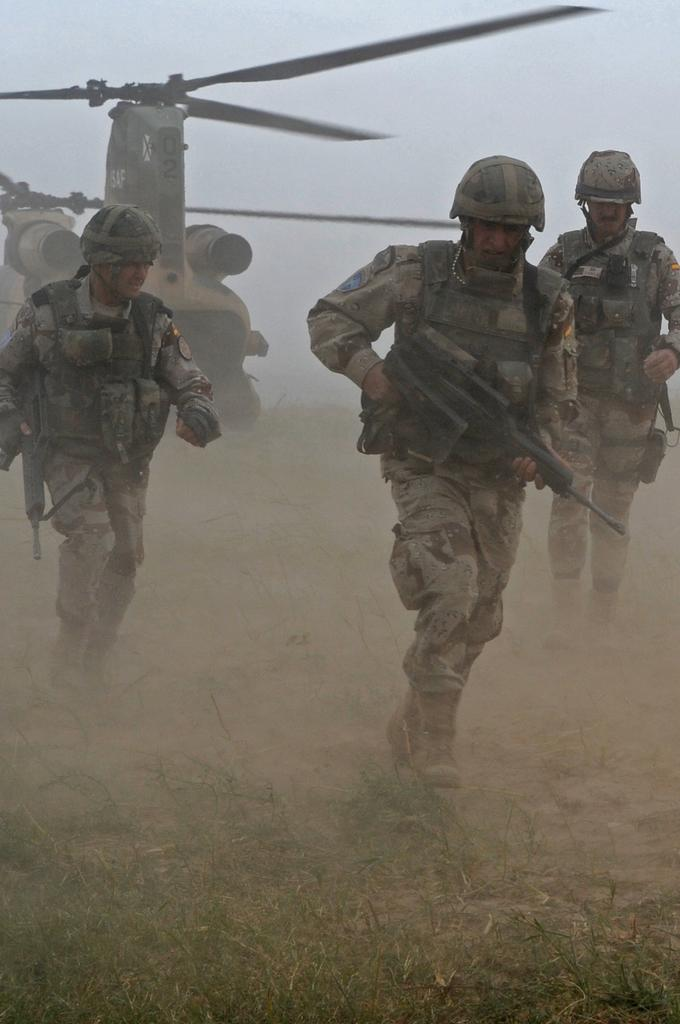How many people are in the image? There are three persons in the image. What are the persons holding in the image? The persons are holding guns. What action are the persons performing in the image? The persons are running. What can be seen in the background of the image? There is a helicopter in the background of the image. What type of terrain is visible in the image? There is grass and ground visible in the image. What type of sister can be seen playing with ants in the image? There is no sister or ants present in the image. What type of minister is depicted in the image? There is no minister depicted in the image. 